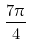<formula> <loc_0><loc_0><loc_500><loc_500>\frac { 7 \pi } { 4 }</formula> 